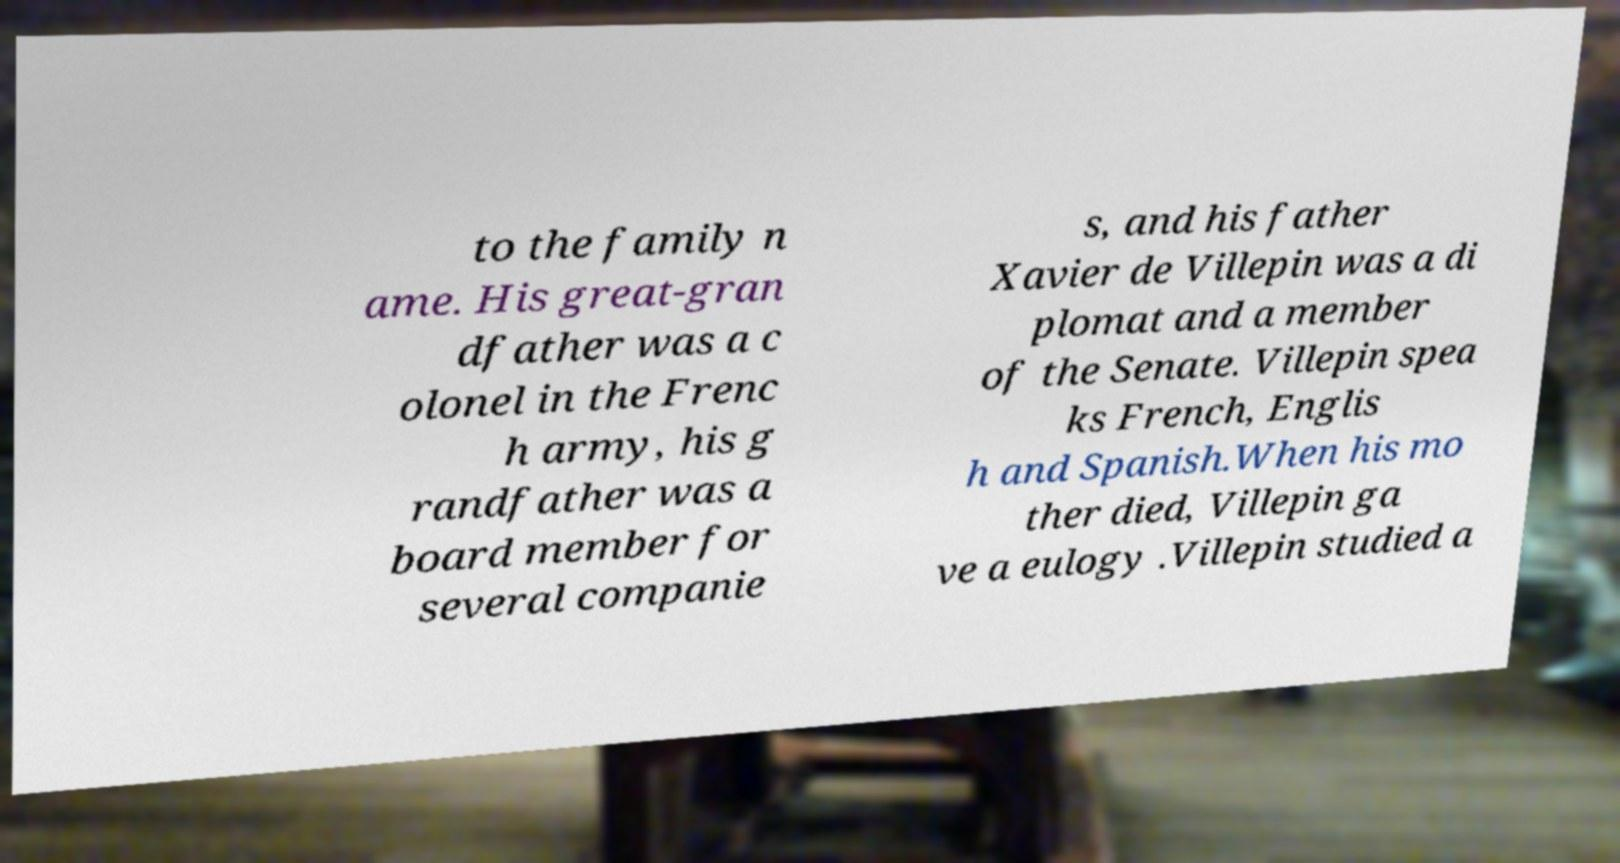What messages or text are displayed in this image? I need them in a readable, typed format. to the family n ame. His great-gran dfather was a c olonel in the Frenc h army, his g randfather was a board member for several companie s, and his father Xavier de Villepin was a di plomat and a member of the Senate. Villepin spea ks French, Englis h and Spanish.When his mo ther died, Villepin ga ve a eulogy .Villepin studied a 